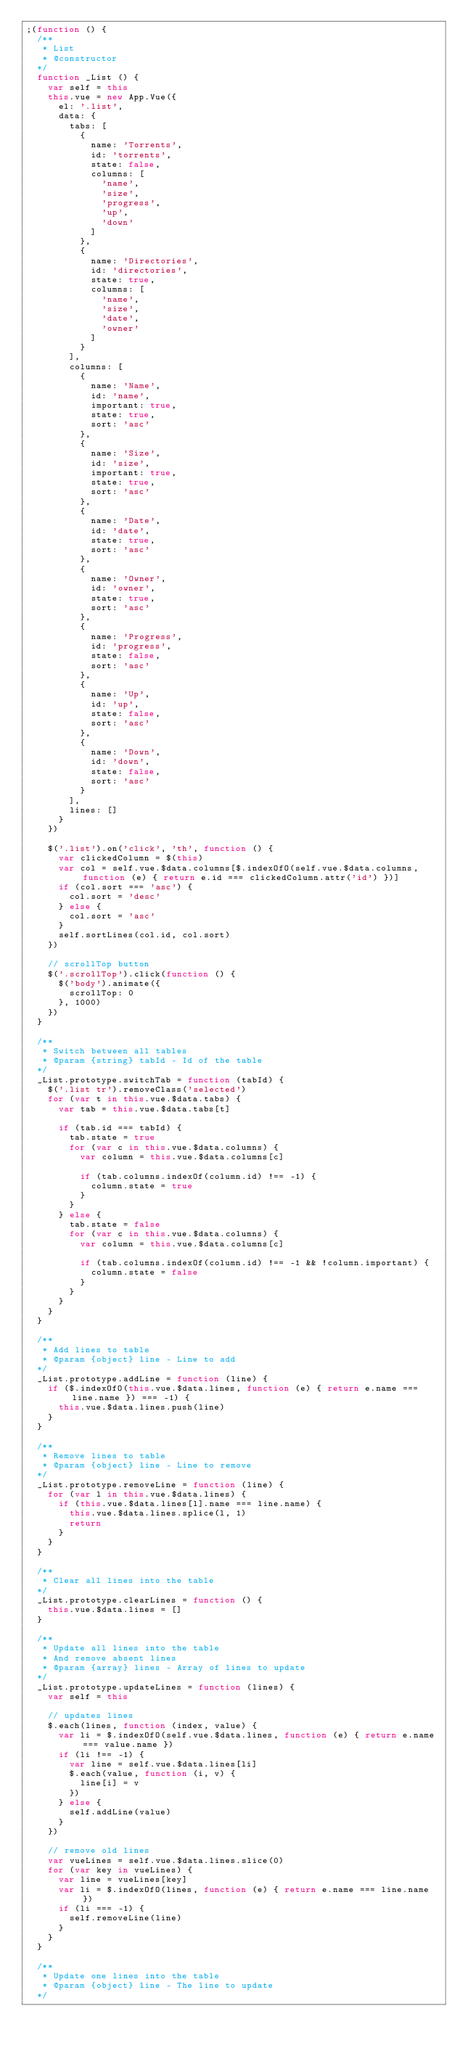<code> <loc_0><loc_0><loc_500><loc_500><_JavaScript_>;(function () {
  /**
   * List
   * @constructor
  */
  function _List () {
    var self = this
    this.vue = new App.Vue({
      el: '.list',
      data: {
        tabs: [
          {
            name: 'Torrents',
            id: 'torrents',
            state: false,
            columns: [
              'name',
              'size',
              'progress',
              'up',
              'down'
            ]
          },
          {
            name: 'Directories',
            id: 'directories',
            state: true,
            columns: [
              'name',
              'size',
              'date',
              'owner'
            ]
          }
        ],
        columns: [
          {
            name: 'Name',
            id: 'name',
            important: true,
            state: true,
            sort: 'asc'
          },
          {
            name: 'Size',
            id: 'size',
            important: true,
            state: true,
            sort: 'asc'
          },
          {
            name: 'Date',
            id: 'date',
            state: true,
            sort: 'asc'
          },
          {
            name: 'Owner',
            id: 'owner',
            state: true,
            sort: 'asc'
          },
          {
            name: 'Progress',
            id: 'progress',
            state: false,
            sort: 'asc'
          },
          {
            name: 'Up',
            id: 'up',
            state: false,
            sort: 'asc'
          },
          {
            name: 'Down',
            id: 'down',
            state: false,
            sort: 'asc'
          }
        ],
        lines: []
      }
    })

    $('.list').on('click', 'th', function () {
      var clickedColumn = $(this)
      var col = self.vue.$data.columns[$.indexOfO(self.vue.$data.columns, function (e) { return e.id === clickedColumn.attr('id') })]
      if (col.sort === 'asc') {
        col.sort = 'desc'
      } else {
        col.sort = 'asc'
      }
      self.sortLines(col.id, col.sort)
    })

    // scrollTop button
    $('.scrollTop').click(function () {
      $('body').animate({
        scrollTop: 0
      }, 1000)
    })
  }

  /**
   * Switch between all tables
   * @param {string} tabId - Id of the table
  */
  _List.prototype.switchTab = function (tabId) {
    $('.list tr').removeClass('selected')
    for (var t in this.vue.$data.tabs) {
      var tab = this.vue.$data.tabs[t]

      if (tab.id === tabId) {
        tab.state = true
        for (var c in this.vue.$data.columns) {
          var column = this.vue.$data.columns[c]

          if (tab.columns.indexOf(column.id) !== -1) {
            column.state = true
          }
        }
      } else {
        tab.state = false
        for (var c in this.vue.$data.columns) {
          var column = this.vue.$data.columns[c]

          if (tab.columns.indexOf(column.id) !== -1 && !column.important) {
            column.state = false
          }
        }
      }
    }
  }

  /**
   * Add lines to table
   * @param {object} line - Line to add
  */
  _List.prototype.addLine = function (line) {
    if ($.indexOfO(this.vue.$data.lines, function (e) { return e.name === line.name }) === -1) {
      this.vue.$data.lines.push(line)
    }
  }

  /**
   * Remove lines to table
   * @param {object} line - Line to remove
  */
  _List.prototype.removeLine = function (line) {
    for (var l in this.vue.$data.lines) {
      if (this.vue.$data.lines[l].name === line.name) {
        this.vue.$data.lines.splice(l, 1)
        return
      }
    }
  }

  /**
   * Clear all lines into the table
  */
  _List.prototype.clearLines = function () {
    this.vue.$data.lines = []
  }

  /**
   * Update all lines into the table
   * And remove absent lines
   * @param {array} lines - Array of lines to update
  */
  _List.prototype.updateLines = function (lines) {
    var self = this

    // updates lines
    $.each(lines, function (index, value) {
      var li = $.indexOfO(self.vue.$data.lines, function (e) { return e.name === value.name })
      if (li !== -1) {
        var line = self.vue.$data.lines[li]
        $.each(value, function (i, v) {
          line[i] = v
        })
      } else {
        self.addLine(value)
      }
    })

    // remove old lines
    var vueLines = self.vue.$data.lines.slice(0)
    for (var key in vueLines) {
      var line = vueLines[key]
      var li = $.indexOfO(lines, function (e) { return e.name === line.name })
      if (li === -1) {
        self.removeLine(line)
      }
    }
  }

  /**
   * Update one lines into the table
   * @param {object} line - The line to update
  */</code> 